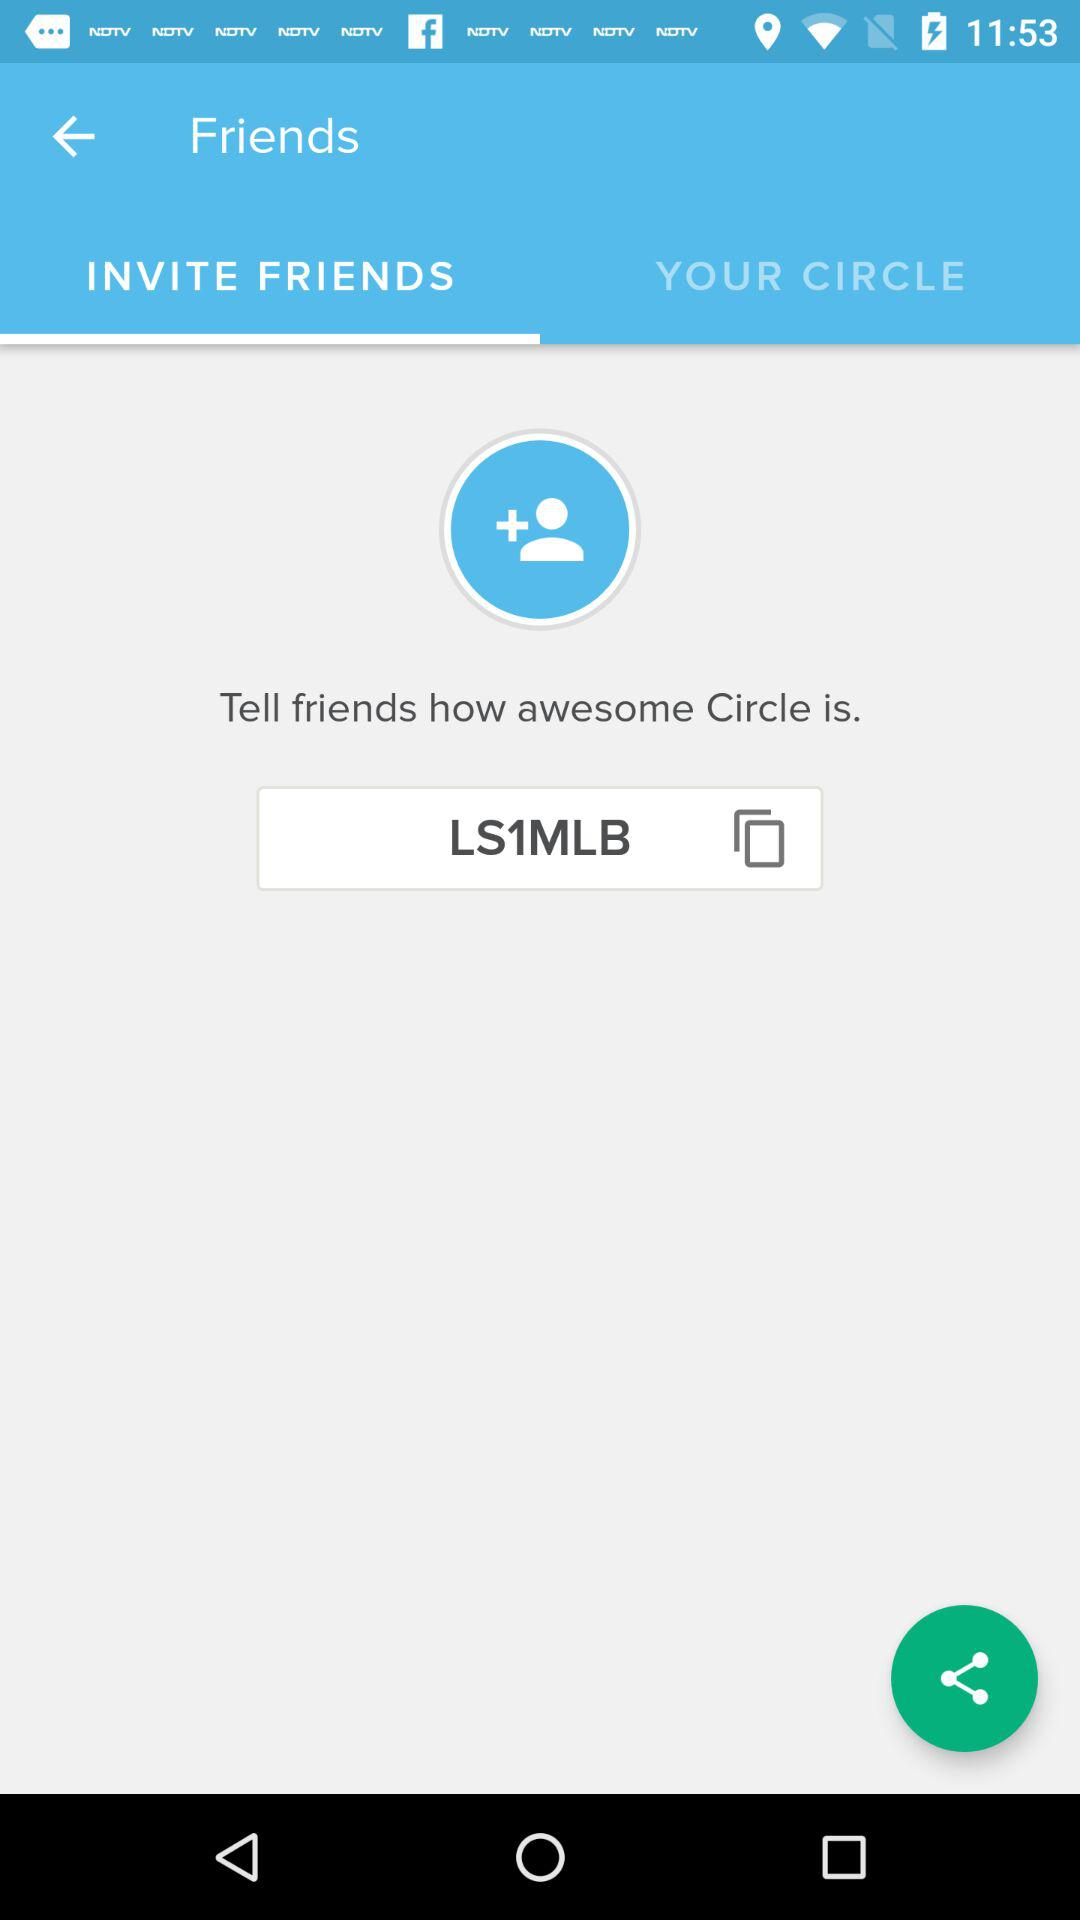Which tab has been selected? The tab "INVITE FRIENDS" has been selected. 